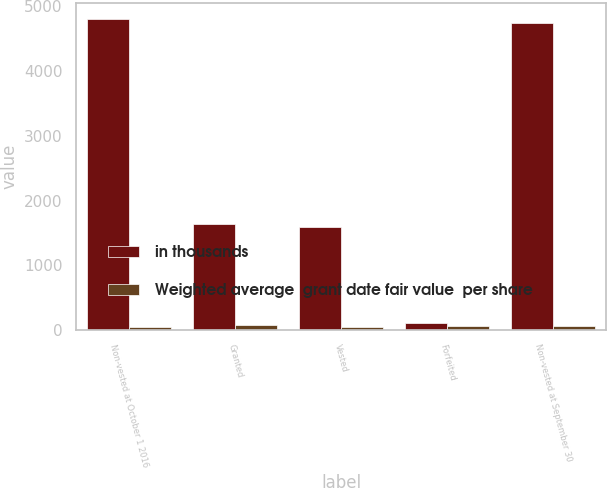<chart> <loc_0><loc_0><loc_500><loc_500><stacked_bar_chart><ecel><fcel>Non-vested at October 1 2016<fcel>Granted<fcel>Vested<fcel>Forfeited<fcel>Non-vested at September 30<nl><fcel>in thousands<fcel>4807<fcel>1637<fcel>1587<fcel>113<fcel>4744<nl><fcel>Weighted average  grant date fair value  per share<fcel>47.71<fcel>72.39<fcel>38.68<fcel>60.11<fcel>58.94<nl></chart> 